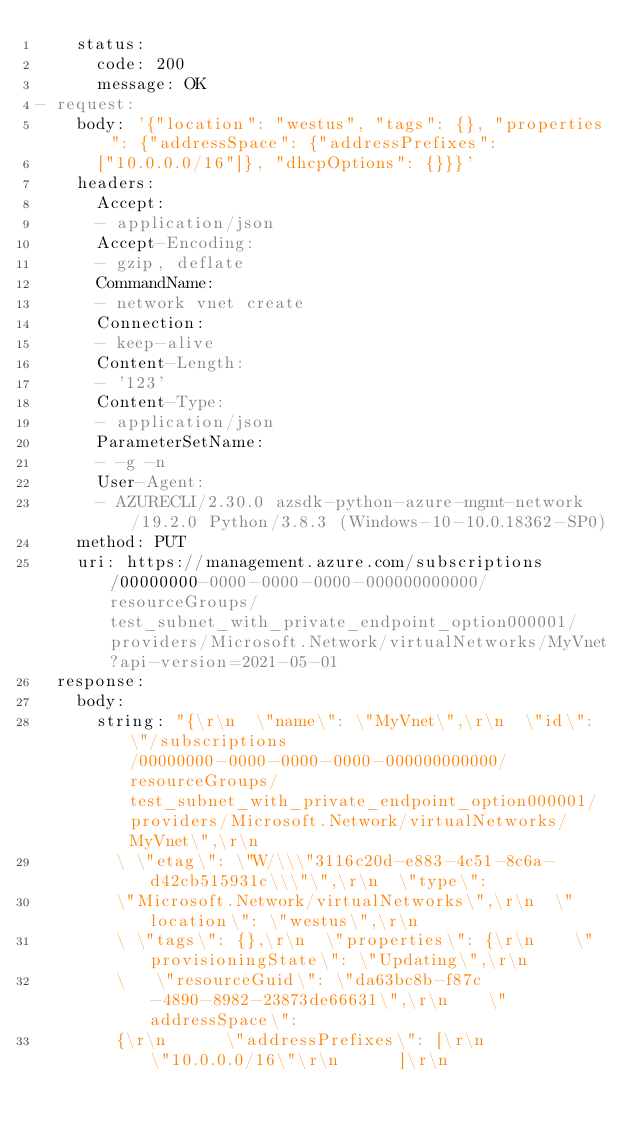Convert code to text. <code><loc_0><loc_0><loc_500><loc_500><_YAML_>    status:
      code: 200
      message: OK
- request:
    body: '{"location": "westus", "tags": {}, "properties": {"addressSpace": {"addressPrefixes":
      ["10.0.0.0/16"]}, "dhcpOptions": {}}}'
    headers:
      Accept:
      - application/json
      Accept-Encoding:
      - gzip, deflate
      CommandName:
      - network vnet create
      Connection:
      - keep-alive
      Content-Length:
      - '123'
      Content-Type:
      - application/json
      ParameterSetName:
      - -g -n
      User-Agent:
      - AZURECLI/2.30.0 azsdk-python-azure-mgmt-network/19.2.0 Python/3.8.3 (Windows-10-10.0.18362-SP0)
    method: PUT
    uri: https://management.azure.com/subscriptions/00000000-0000-0000-0000-000000000000/resourceGroups/test_subnet_with_private_endpoint_option000001/providers/Microsoft.Network/virtualNetworks/MyVnet?api-version=2021-05-01
  response:
    body:
      string: "{\r\n  \"name\": \"MyVnet\",\r\n  \"id\": \"/subscriptions/00000000-0000-0000-0000-000000000000/resourceGroups/test_subnet_with_private_endpoint_option000001/providers/Microsoft.Network/virtualNetworks/MyVnet\",\r\n
        \ \"etag\": \"W/\\\"3116c20d-e883-4c51-8c6a-d42cb515931c\\\"\",\r\n  \"type\":
        \"Microsoft.Network/virtualNetworks\",\r\n  \"location\": \"westus\",\r\n
        \ \"tags\": {},\r\n  \"properties\": {\r\n    \"provisioningState\": \"Updating\",\r\n
        \   \"resourceGuid\": \"da63bc8b-f87c-4890-8982-23873de66631\",\r\n    \"addressSpace\":
        {\r\n      \"addressPrefixes\": [\r\n        \"10.0.0.0/16\"\r\n      ]\r\n</code> 